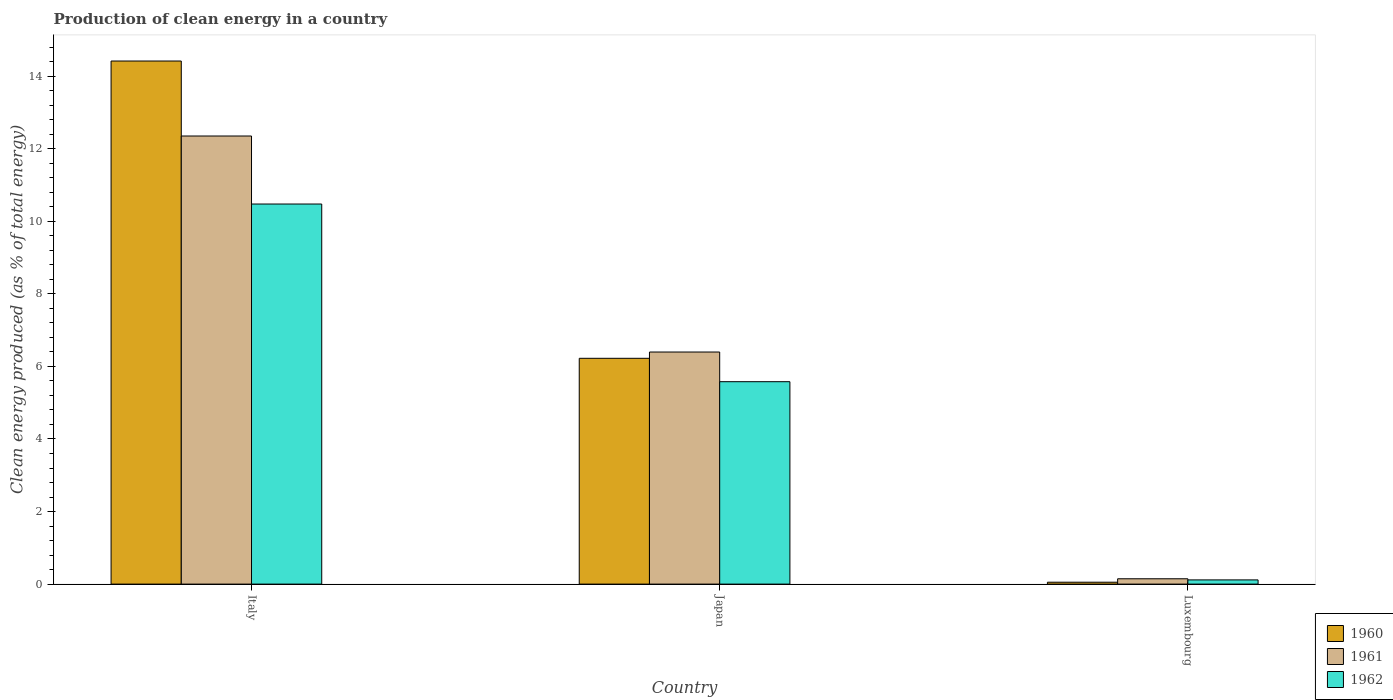How many groups of bars are there?
Give a very brief answer. 3. Are the number of bars per tick equal to the number of legend labels?
Make the answer very short. Yes. Are the number of bars on each tick of the X-axis equal?
Offer a very short reply. Yes. How many bars are there on the 2nd tick from the left?
Your response must be concise. 3. What is the label of the 1st group of bars from the left?
Ensure brevity in your answer.  Italy. What is the percentage of clean energy produced in 1961 in Italy?
Provide a short and direct response. 12.35. Across all countries, what is the maximum percentage of clean energy produced in 1961?
Ensure brevity in your answer.  12.35. Across all countries, what is the minimum percentage of clean energy produced in 1962?
Your answer should be compact. 0.12. In which country was the percentage of clean energy produced in 1960 maximum?
Your response must be concise. Italy. In which country was the percentage of clean energy produced in 1961 minimum?
Offer a terse response. Luxembourg. What is the total percentage of clean energy produced in 1962 in the graph?
Give a very brief answer. 16.17. What is the difference between the percentage of clean energy produced in 1961 in Italy and that in Luxembourg?
Provide a succinct answer. 12.2. What is the difference between the percentage of clean energy produced in 1961 in Japan and the percentage of clean energy produced in 1962 in Luxembourg?
Give a very brief answer. 6.28. What is the average percentage of clean energy produced in 1962 per country?
Offer a terse response. 5.39. What is the difference between the percentage of clean energy produced of/in 1961 and percentage of clean energy produced of/in 1962 in Japan?
Ensure brevity in your answer.  0.82. In how many countries, is the percentage of clean energy produced in 1961 greater than 6.8 %?
Your answer should be very brief. 1. What is the ratio of the percentage of clean energy produced in 1962 in Italy to that in Luxembourg?
Ensure brevity in your answer.  90.43. Is the difference between the percentage of clean energy produced in 1961 in Italy and Japan greater than the difference between the percentage of clean energy produced in 1962 in Italy and Japan?
Offer a terse response. Yes. What is the difference between the highest and the second highest percentage of clean energy produced in 1961?
Provide a short and direct response. -12.2. What is the difference between the highest and the lowest percentage of clean energy produced in 1961?
Offer a terse response. 12.2. What does the 1st bar from the left in Japan represents?
Make the answer very short. 1960. Is it the case that in every country, the sum of the percentage of clean energy produced in 1962 and percentage of clean energy produced in 1960 is greater than the percentage of clean energy produced in 1961?
Keep it short and to the point. Yes. Are all the bars in the graph horizontal?
Provide a succinct answer. No. What is the difference between two consecutive major ticks on the Y-axis?
Your answer should be very brief. 2. Are the values on the major ticks of Y-axis written in scientific E-notation?
Offer a very short reply. No. Does the graph contain grids?
Your answer should be very brief. No. Where does the legend appear in the graph?
Make the answer very short. Bottom right. How are the legend labels stacked?
Provide a succinct answer. Vertical. What is the title of the graph?
Offer a very short reply. Production of clean energy in a country. What is the label or title of the Y-axis?
Your response must be concise. Clean energy produced (as % of total energy). What is the Clean energy produced (as % of total energy) of 1960 in Italy?
Offer a very short reply. 14.42. What is the Clean energy produced (as % of total energy) in 1961 in Italy?
Your response must be concise. 12.35. What is the Clean energy produced (as % of total energy) in 1962 in Italy?
Ensure brevity in your answer.  10.48. What is the Clean energy produced (as % of total energy) in 1960 in Japan?
Make the answer very short. 6.22. What is the Clean energy produced (as % of total energy) of 1961 in Japan?
Provide a short and direct response. 6.4. What is the Clean energy produced (as % of total energy) of 1962 in Japan?
Your response must be concise. 5.58. What is the Clean energy produced (as % of total energy) in 1960 in Luxembourg?
Your answer should be very brief. 0.05. What is the Clean energy produced (as % of total energy) of 1961 in Luxembourg?
Offer a very short reply. 0.15. What is the Clean energy produced (as % of total energy) in 1962 in Luxembourg?
Offer a terse response. 0.12. Across all countries, what is the maximum Clean energy produced (as % of total energy) of 1960?
Provide a succinct answer. 14.42. Across all countries, what is the maximum Clean energy produced (as % of total energy) of 1961?
Give a very brief answer. 12.35. Across all countries, what is the maximum Clean energy produced (as % of total energy) of 1962?
Provide a succinct answer. 10.48. Across all countries, what is the minimum Clean energy produced (as % of total energy) of 1960?
Keep it short and to the point. 0.05. Across all countries, what is the minimum Clean energy produced (as % of total energy) in 1961?
Keep it short and to the point. 0.15. Across all countries, what is the minimum Clean energy produced (as % of total energy) of 1962?
Ensure brevity in your answer.  0.12. What is the total Clean energy produced (as % of total energy) of 1960 in the graph?
Your answer should be very brief. 20.69. What is the total Clean energy produced (as % of total energy) of 1961 in the graph?
Keep it short and to the point. 18.89. What is the total Clean energy produced (as % of total energy) in 1962 in the graph?
Make the answer very short. 16.17. What is the difference between the Clean energy produced (as % of total energy) in 1960 in Italy and that in Japan?
Keep it short and to the point. 8.19. What is the difference between the Clean energy produced (as % of total energy) of 1961 in Italy and that in Japan?
Keep it short and to the point. 5.95. What is the difference between the Clean energy produced (as % of total energy) of 1962 in Italy and that in Japan?
Make the answer very short. 4.9. What is the difference between the Clean energy produced (as % of total energy) of 1960 in Italy and that in Luxembourg?
Offer a very short reply. 14.37. What is the difference between the Clean energy produced (as % of total energy) of 1961 in Italy and that in Luxembourg?
Give a very brief answer. 12.2. What is the difference between the Clean energy produced (as % of total energy) in 1962 in Italy and that in Luxembourg?
Your response must be concise. 10.36. What is the difference between the Clean energy produced (as % of total energy) in 1960 in Japan and that in Luxembourg?
Your response must be concise. 6.17. What is the difference between the Clean energy produced (as % of total energy) of 1961 in Japan and that in Luxembourg?
Provide a short and direct response. 6.25. What is the difference between the Clean energy produced (as % of total energy) of 1962 in Japan and that in Luxembourg?
Your answer should be compact. 5.46. What is the difference between the Clean energy produced (as % of total energy) of 1960 in Italy and the Clean energy produced (as % of total energy) of 1961 in Japan?
Make the answer very short. 8.02. What is the difference between the Clean energy produced (as % of total energy) in 1960 in Italy and the Clean energy produced (as % of total energy) in 1962 in Japan?
Make the answer very short. 8.84. What is the difference between the Clean energy produced (as % of total energy) in 1961 in Italy and the Clean energy produced (as % of total energy) in 1962 in Japan?
Ensure brevity in your answer.  6.77. What is the difference between the Clean energy produced (as % of total energy) in 1960 in Italy and the Clean energy produced (as % of total energy) in 1961 in Luxembourg?
Your answer should be very brief. 14.27. What is the difference between the Clean energy produced (as % of total energy) in 1960 in Italy and the Clean energy produced (as % of total energy) in 1962 in Luxembourg?
Your answer should be compact. 14.3. What is the difference between the Clean energy produced (as % of total energy) in 1961 in Italy and the Clean energy produced (as % of total energy) in 1962 in Luxembourg?
Offer a terse response. 12.23. What is the difference between the Clean energy produced (as % of total energy) in 1960 in Japan and the Clean energy produced (as % of total energy) in 1961 in Luxembourg?
Give a very brief answer. 6.08. What is the difference between the Clean energy produced (as % of total energy) of 1960 in Japan and the Clean energy produced (as % of total energy) of 1962 in Luxembourg?
Your answer should be very brief. 6.11. What is the difference between the Clean energy produced (as % of total energy) in 1961 in Japan and the Clean energy produced (as % of total energy) in 1962 in Luxembourg?
Offer a very short reply. 6.28. What is the average Clean energy produced (as % of total energy) of 1960 per country?
Give a very brief answer. 6.9. What is the average Clean energy produced (as % of total energy) in 1961 per country?
Your response must be concise. 6.3. What is the average Clean energy produced (as % of total energy) of 1962 per country?
Your answer should be very brief. 5.39. What is the difference between the Clean energy produced (as % of total energy) in 1960 and Clean energy produced (as % of total energy) in 1961 in Italy?
Your answer should be very brief. 2.07. What is the difference between the Clean energy produced (as % of total energy) of 1960 and Clean energy produced (as % of total energy) of 1962 in Italy?
Make the answer very short. 3.94. What is the difference between the Clean energy produced (as % of total energy) in 1961 and Clean energy produced (as % of total energy) in 1962 in Italy?
Your answer should be very brief. 1.87. What is the difference between the Clean energy produced (as % of total energy) of 1960 and Clean energy produced (as % of total energy) of 1961 in Japan?
Provide a succinct answer. -0.17. What is the difference between the Clean energy produced (as % of total energy) in 1960 and Clean energy produced (as % of total energy) in 1962 in Japan?
Keep it short and to the point. 0.64. What is the difference between the Clean energy produced (as % of total energy) in 1961 and Clean energy produced (as % of total energy) in 1962 in Japan?
Offer a terse response. 0.82. What is the difference between the Clean energy produced (as % of total energy) of 1960 and Clean energy produced (as % of total energy) of 1961 in Luxembourg?
Ensure brevity in your answer.  -0.09. What is the difference between the Clean energy produced (as % of total energy) of 1960 and Clean energy produced (as % of total energy) of 1962 in Luxembourg?
Provide a short and direct response. -0.06. What is the difference between the Clean energy produced (as % of total energy) of 1961 and Clean energy produced (as % of total energy) of 1962 in Luxembourg?
Your response must be concise. 0.03. What is the ratio of the Clean energy produced (as % of total energy) of 1960 in Italy to that in Japan?
Give a very brief answer. 2.32. What is the ratio of the Clean energy produced (as % of total energy) in 1961 in Italy to that in Japan?
Give a very brief answer. 1.93. What is the ratio of the Clean energy produced (as % of total energy) of 1962 in Italy to that in Japan?
Provide a succinct answer. 1.88. What is the ratio of the Clean energy produced (as % of total energy) in 1960 in Italy to that in Luxembourg?
Your answer should be compact. 276.95. What is the ratio of the Clean energy produced (as % of total energy) in 1961 in Italy to that in Luxembourg?
Keep it short and to the point. 84.09. What is the ratio of the Clean energy produced (as % of total energy) of 1962 in Italy to that in Luxembourg?
Provide a succinct answer. 90.43. What is the ratio of the Clean energy produced (as % of total energy) in 1960 in Japan to that in Luxembourg?
Offer a very short reply. 119.55. What is the ratio of the Clean energy produced (as % of total energy) in 1961 in Japan to that in Luxembourg?
Ensure brevity in your answer.  43.55. What is the ratio of the Clean energy produced (as % of total energy) in 1962 in Japan to that in Luxembourg?
Provide a succinct answer. 48.16. What is the difference between the highest and the second highest Clean energy produced (as % of total energy) in 1960?
Keep it short and to the point. 8.19. What is the difference between the highest and the second highest Clean energy produced (as % of total energy) of 1961?
Your answer should be compact. 5.95. What is the difference between the highest and the second highest Clean energy produced (as % of total energy) of 1962?
Make the answer very short. 4.9. What is the difference between the highest and the lowest Clean energy produced (as % of total energy) of 1960?
Provide a succinct answer. 14.37. What is the difference between the highest and the lowest Clean energy produced (as % of total energy) in 1961?
Provide a short and direct response. 12.2. What is the difference between the highest and the lowest Clean energy produced (as % of total energy) of 1962?
Provide a short and direct response. 10.36. 